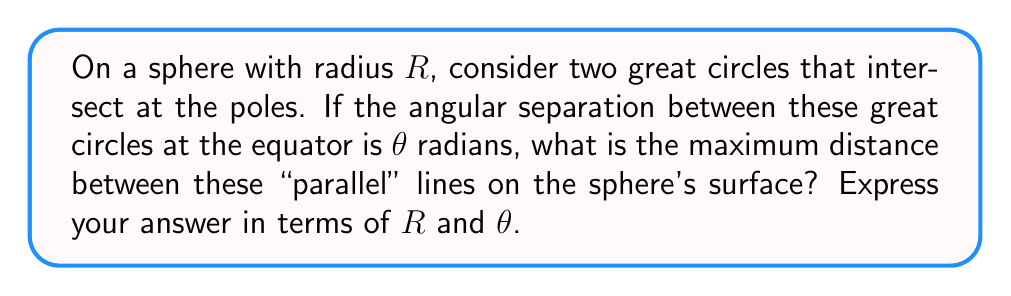What is the answer to this math problem? Let's approach this step-by-step:

1) In spherical geometry, "parallel" lines are great circles that intersect at antipodal points (in this case, the poles).

2) The distance between these great circles varies along the sphere's surface, reaching a maximum at the equator.

3) At the equator, the angular separation between the great circles is $\theta$ radians.

4) The distance along the equator between these points is an arc of a great circle. We can calculate this using the formula for arc length:

   $s = R\theta$

   where $s$ is the arc length, $R$ is the radius, and $\theta$ is the angle in radians.

5) However, this is not the maximum distance between the "parallel" lines. The maximum distance is along a geodesic (shortest path) perpendicular to both great circles.

6) This geodesic forms a right spherical triangle with the two great circles and the equator.

7) In a right spherical triangle, we can use the spherical version of the Pythagorean theorem:

   $\cos(c) = \cos(a)\cos(b)$

   where $c$ is the hypotenuse and $a$ and $b$ are the other two sides (all measured as central angles).

8) In our case, $b = \frac{\pi}{2}$ (quarter of a great circle from pole to equator), and $a = \frac{\theta}{2}$ (half the angular separation at the equator).

9) Substituting into the spherical Pythagorean theorem:

   $\cos(c) = \cos(\frac{\theta}{2})\cos(\frac{\pi}{2}) = 0$

10) This means $c = \frac{\pi}{2}$ radians.

11) The maximum distance is therefore the length of this geodesic:

    $d_{max} = R \cdot \frac{\pi}{2} = \frac{\pi R}{2}$

This result is independent of $\theta$, showing that the maximum distance between any two such "parallel" lines on a sphere is always a quarter of the sphere's circumference.
Answer: $\frac{\pi R}{2}$ 